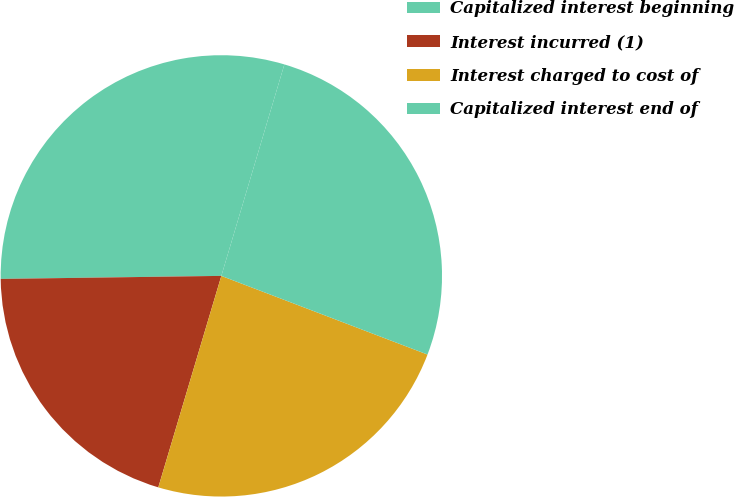Convert chart. <chart><loc_0><loc_0><loc_500><loc_500><pie_chart><fcel>Capitalized interest beginning<fcel>Interest incurred (1)<fcel>Interest charged to cost of<fcel>Capitalized interest end of<nl><fcel>29.83%<fcel>20.17%<fcel>23.81%<fcel>26.19%<nl></chart> 